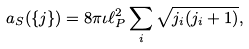<formula> <loc_0><loc_0><loc_500><loc_500>a _ { S } ( \{ j \} ) = 8 \pi \iota \ell ^ { 2 } _ { P } \sum _ { i } \sqrt { j _ { i } ( j _ { i } + 1 ) } ,</formula> 